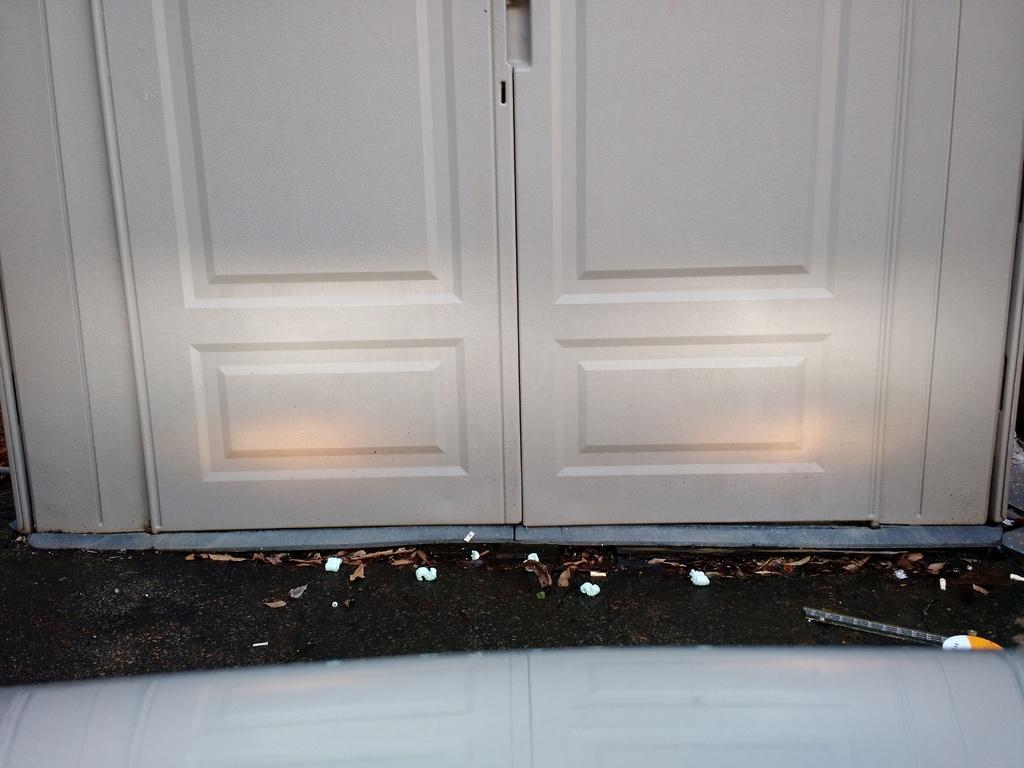Can you describe this image briefly? In this image we can see a door and shredded leaves on the floor. 